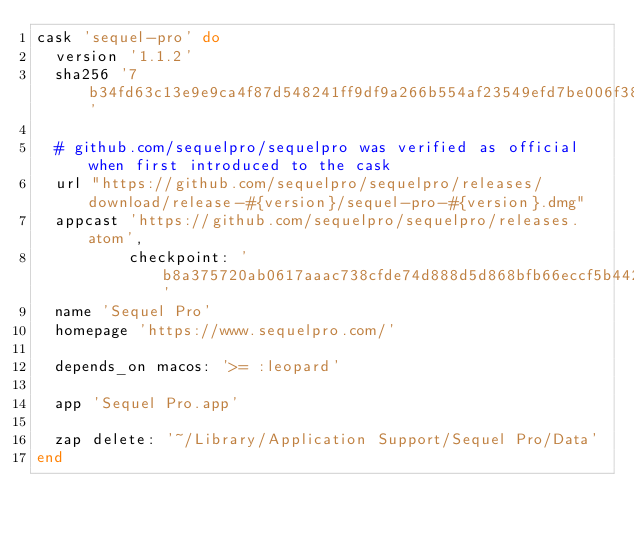Convert code to text. <code><loc_0><loc_0><loc_500><loc_500><_Ruby_>cask 'sequel-pro' do
  version '1.1.2'
  sha256 '7b34fd63c13e9e9ca4f87d548241ff9df9a266b554af23549efd7be006f387c6'

  # github.com/sequelpro/sequelpro was verified as official when first introduced to the cask
  url "https://github.com/sequelpro/sequelpro/releases/download/release-#{version}/sequel-pro-#{version}.dmg"
  appcast 'https://github.com/sequelpro/sequelpro/releases.atom',
          checkpoint: 'b8a375720ab0617aaac738cfde74d888d5d868bfb66eccf5b4426e8b10fb2325'
  name 'Sequel Pro'
  homepage 'https://www.sequelpro.com/'

  depends_on macos: '>= :leopard'

  app 'Sequel Pro.app'

  zap delete: '~/Library/Application Support/Sequel Pro/Data'
end
</code> 